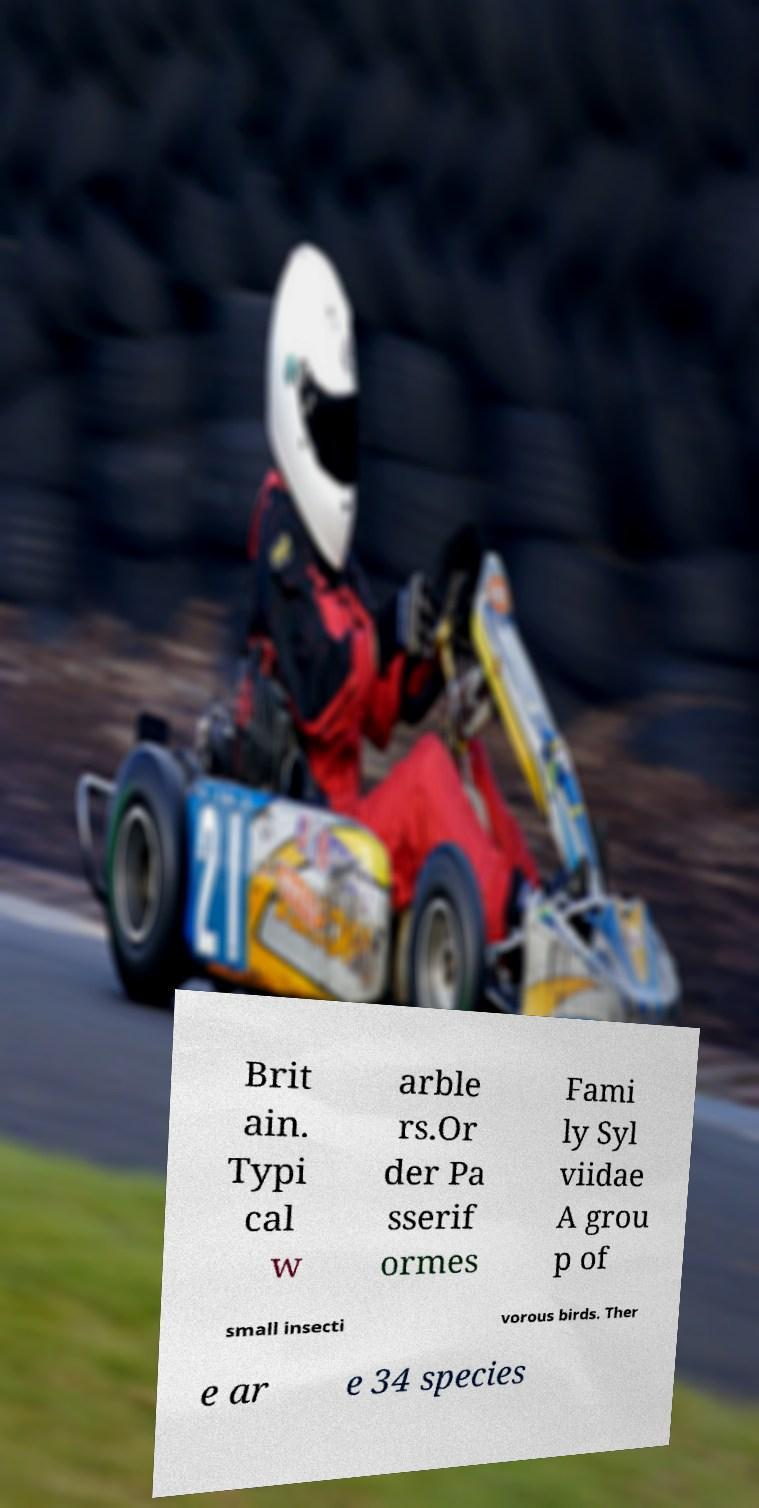Could you assist in decoding the text presented in this image and type it out clearly? Brit ain. Typi cal w arble rs.Or der Pa sserif ormes Fami ly Syl viidae A grou p of small insecti vorous birds. Ther e ar e 34 species 